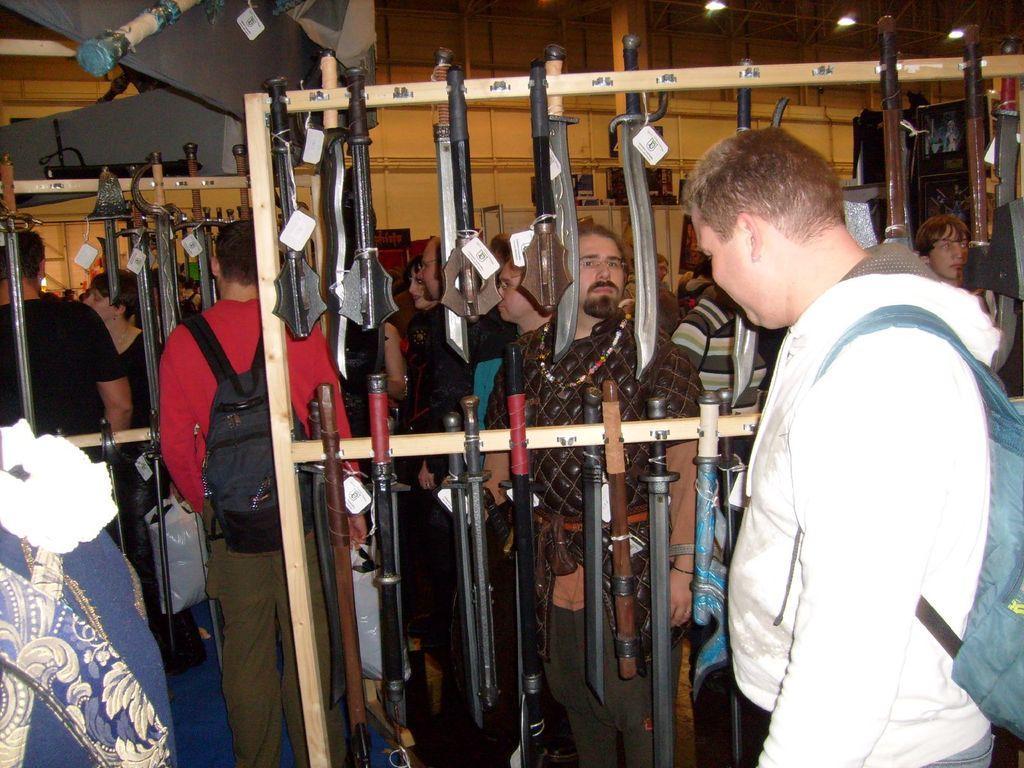How would you summarize this image in a sentence or two? In this picture we can see a group of people carrying bags and standing, swords and in the background we can see the wall. 